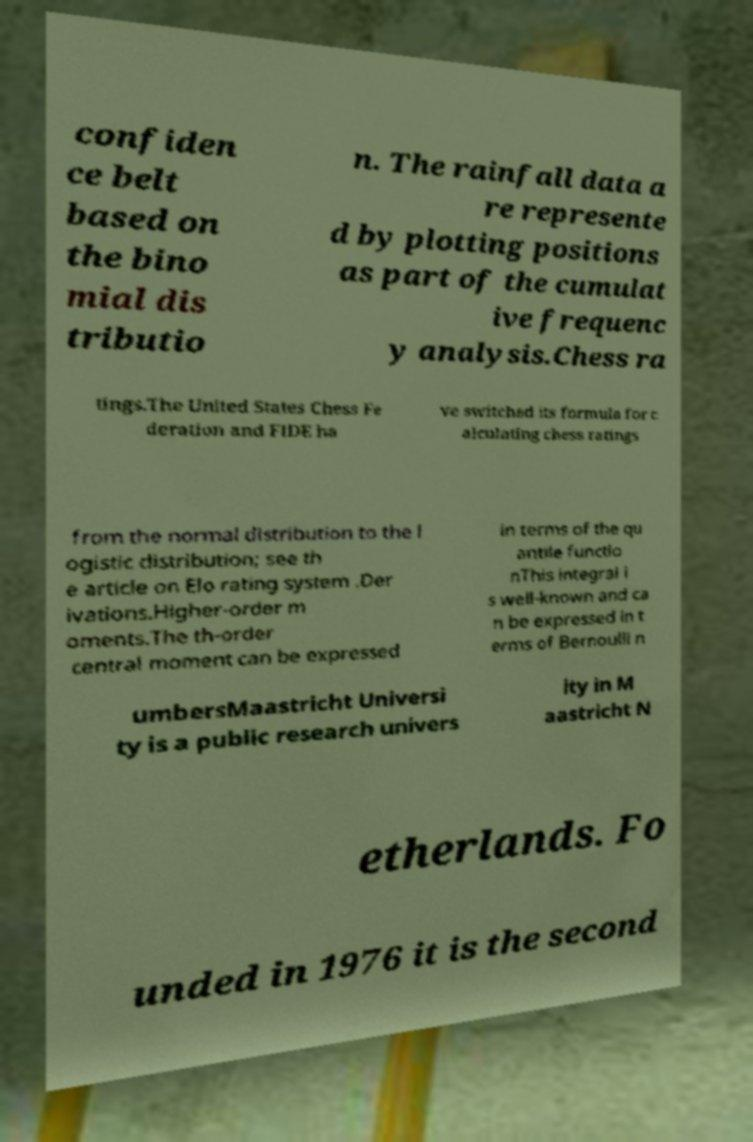Please read and relay the text visible in this image. What does it say? confiden ce belt based on the bino mial dis tributio n. The rainfall data a re represente d by plotting positions as part of the cumulat ive frequenc y analysis.Chess ra tings.The United States Chess Fe deration and FIDE ha ve switched its formula for c alculating chess ratings from the normal distribution to the l ogistic distribution; see th e article on Elo rating system .Der ivations.Higher-order m oments.The th-order central moment can be expressed in terms of the qu antile functio nThis integral i s well-known and ca n be expressed in t erms of Bernoulli n umbersMaastricht Universi ty is a public research univers ity in M aastricht N etherlands. Fo unded in 1976 it is the second 